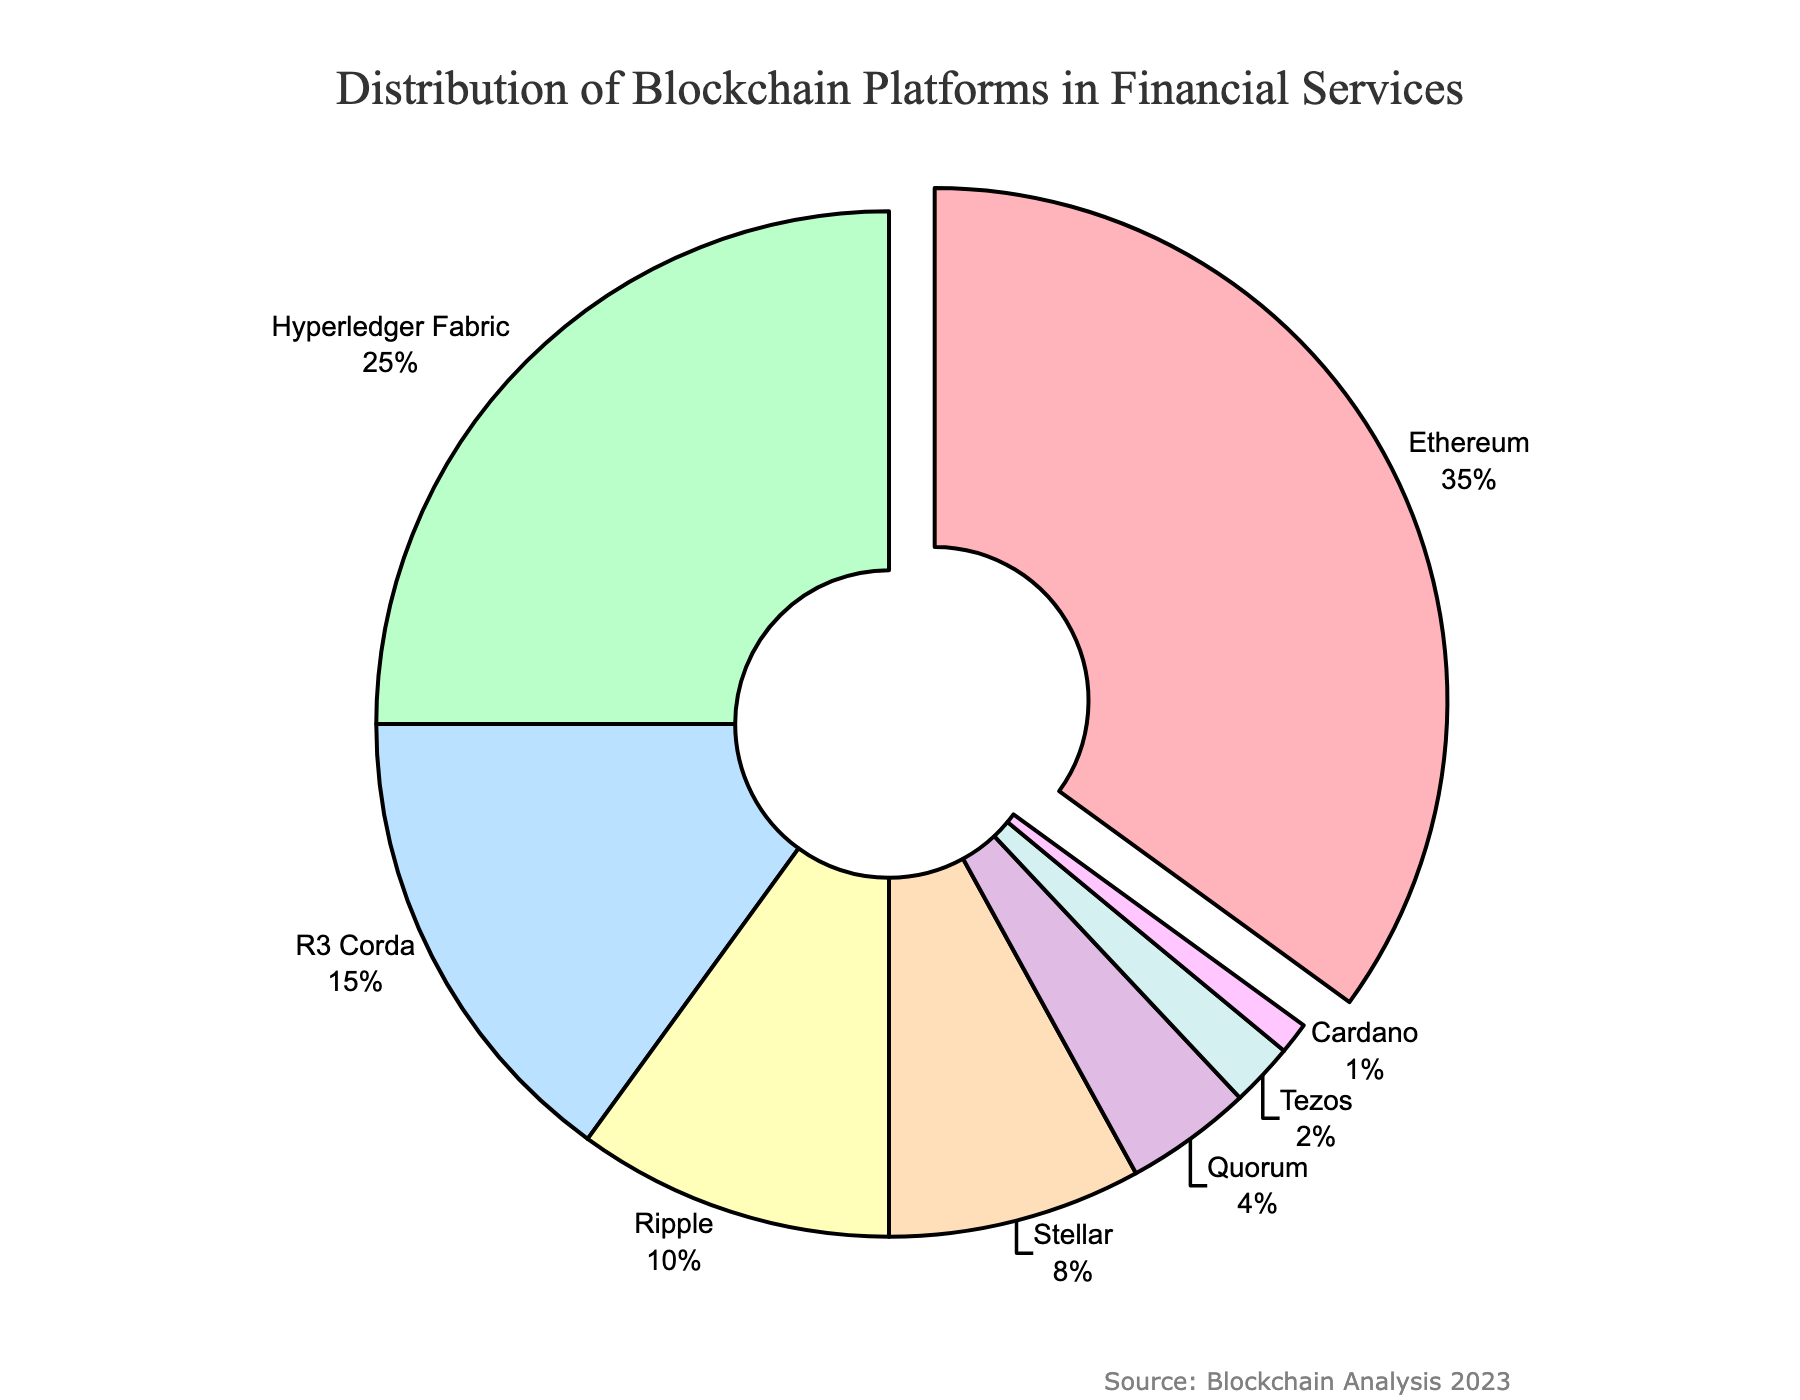What percentage of financial services use Ethereum as their blockchain platform? Ethereum occupies 35% of the chart, as depicted clearly by both the segment's size and the percentage label.
Answer: 35% Which blockchain platform is used the least in financial services, and what is its percentage usage? The segment labeled "Cardano" is the smallest in the chart and its usage is 1%, as indicated by the label.
Answer: Cardano, 1% What is the combined percentage usage of Hyperledger Fabric and R3 Corda? Hyperledger Fabric is labeled with 25% and R3 Corda is labeled with 15%. Adding these together: 25% + 15% = 40%.
Answer: 40% Which blockchain platform is represented by a segment that is visually pulled out from the pie chart, and why? The Ethereum segment is visually emphasized by being pulled out because it has the largest percentage, i.e., 35%, among all the platforms.
Answer: Ethereum How does the usage of Ripple compare to Stellar in financial services? Ripple's segment size and label indicate 10%, whereas Stellar's segment shows 8%. Comparing the two percentages, Ripple (10%) is used more than Stellar (8%).
Answer: Ripple is used more than Stellar What is the difference in usage between the most used (Ethereum) and the least used (Cardano) blockchain platforms? The most used platform is Ethereum at 35%, and the least used is Cardano at 1%. The difference is calculated as: 35% - 1% = 34%.
Answer: 34% What is the total percentage of blockchain platforms that are used in financial services but are not Ethereum, Hyperledger Fabric, or R3 Corda? Ethereum, Hyperledger Fabric, and R3 Corda combined have a usage of 35% + 25% + 15% = 75%. The remaining percentage is 100% - 75% = 25%.
Answer: 25% Which blockchain platforms together comprise less than 10% of the financial services market and what are their individual percentages? Tezos (2%) and Cardano (1%) both individually and collectively represent less than 10% of the usage as depicted in the chart.
Answer: Tezos 2%, Cardano 1% How does the visual representation of Quorum compare to that of Ripple in terms of segment size and percentage? Quorum is labeled with 4% and its segment is smaller compared to Ripple, which has 10%. Visually, the Ripple segment is larger than the Quorum segment.
Answer: Ripple is larger than Quorum Which color represents the R3 Corda segment in the pie chart? The color of the R3 Corda segment can be identified by locating the segment labeled "R3 Corda" which is typically visually distinct from others.
Answer: Identify based on visual reference 